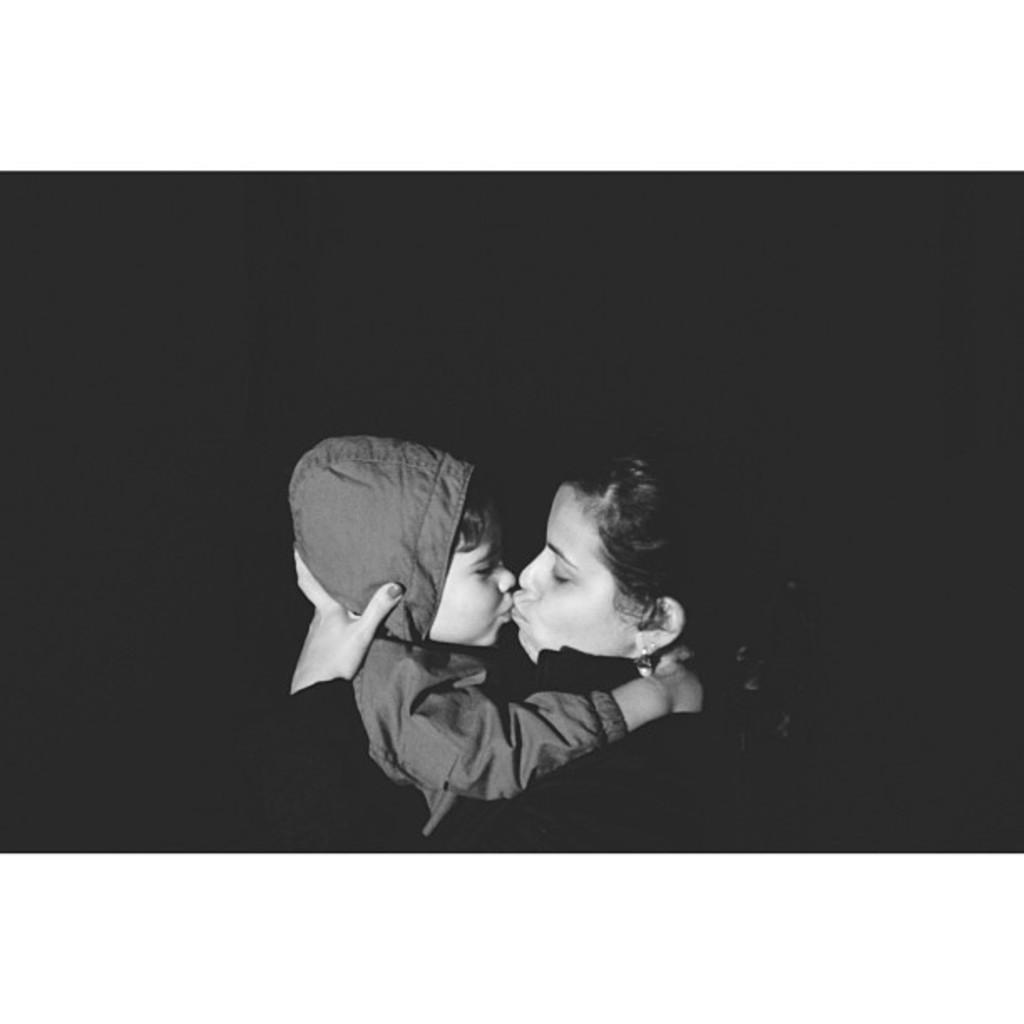What is the color scheme of the image? The image is black and white. Who is present in the image? There is a woman and a child in the image. What are the woman and child wearing? They are both wearing clothes. What is the woman doing to the child? The woman is kissing the child. What can be observed about the background of the image? The background of the image is dark. What type of cake is being judged by the woman in the image? There is no cake present in the image, nor is there any indication of a judging activity. 